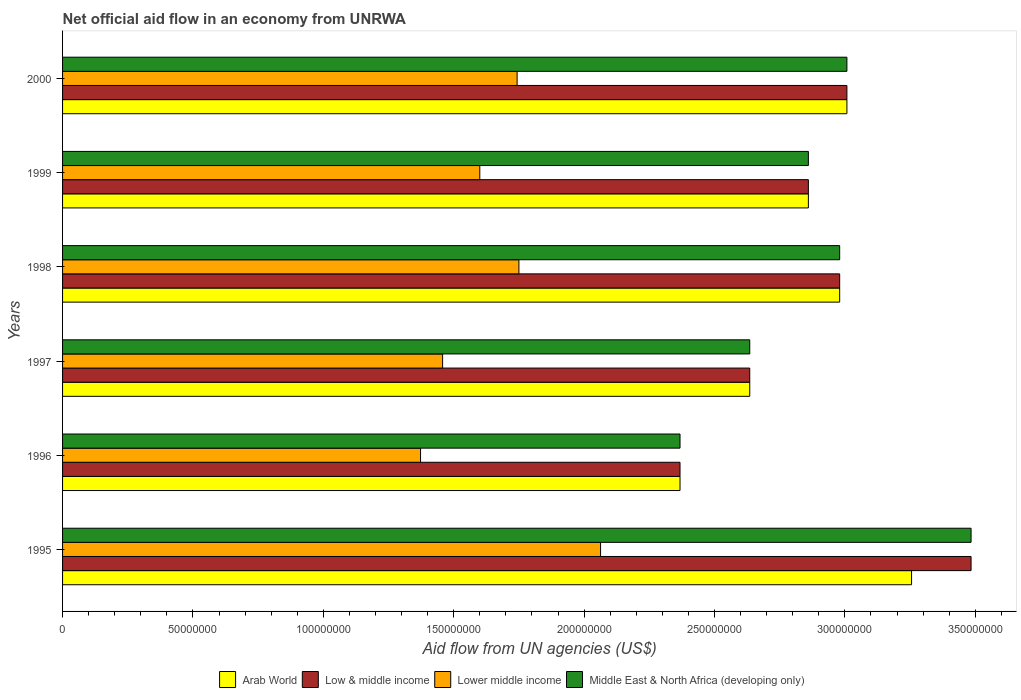How many different coloured bars are there?
Ensure brevity in your answer.  4. How many groups of bars are there?
Your answer should be very brief. 6. Are the number of bars per tick equal to the number of legend labels?
Ensure brevity in your answer.  Yes. How many bars are there on the 5th tick from the top?
Offer a terse response. 4. How many bars are there on the 1st tick from the bottom?
Provide a short and direct response. 4. What is the label of the 5th group of bars from the top?
Keep it short and to the point. 1996. What is the net official aid flow in Lower middle income in 1997?
Keep it short and to the point. 1.46e+08. Across all years, what is the maximum net official aid flow in Middle East & North Africa (developing only)?
Your answer should be very brief. 3.48e+08. Across all years, what is the minimum net official aid flow in Middle East & North Africa (developing only)?
Your answer should be very brief. 2.37e+08. In which year was the net official aid flow in Low & middle income maximum?
Your answer should be compact. 1995. What is the total net official aid flow in Middle East & North Africa (developing only) in the graph?
Offer a terse response. 1.73e+09. What is the difference between the net official aid flow in Middle East & North Africa (developing only) in 1995 and that in 1999?
Keep it short and to the point. 6.24e+07. What is the difference between the net official aid flow in Arab World in 2000 and the net official aid flow in Middle East & North Africa (developing only) in 1999?
Provide a succinct answer. 1.48e+07. What is the average net official aid flow in Lower middle income per year?
Your answer should be compact. 1.66e+08. In the year 1995, what is the difference between the net official aid flow in Middle East & North Africa (developing only) and net official aid flow in Arab World?
Offer a terse response. 2.28e+07. What is the ratio of the net official aid flow in Lower middle income in 1998 to that in 2000?
Your answer should be compact. 1. Is the net official aid flow in Lower middle income in 1997 less than that in 2000?
Provide a succinct answer. Yes. Is the difference between the net official aid flow in Middle East & North Africa (developing only) in 1996 and 1998 greater than the difference between the net official aid flow in Arab World in 1996 and 1998?
Your answer should be very brief. No. What is the difference between the highest and the second highest net official aid flow in Low & middle income?
Keep it short and to the point. 4.76e+07. What is the difference between the highest and the lowest net official aid flow in Low & middle income?
Provide a succinct answer. 1.12e+08. Is the sum of the net official aid flow in Arab World in 1995 and 1999 greater than the maximum net official aid flow in Low & middle income across all years?
Make the answer very short. Yes. Is it the case that in every year, the sum of the net official aid flow in Lower middle income and net official aid flow in Arab World is greater than the sum of net official aid flow in Middle East & North Africa (developing only) and net official aid flow in Low & middle income?
Your response must be concise. No. What does the 1st bar from the top in 1999 represents?
Give a very brief answer. Middle East & North Africa (developing only). What does the 4th bar from the bottom in 1999 represents?
Offer a terse response. Middle East & North Africa (developing only). Is it the case that in every year, the sum of the net official aid flow in Arab World and net official aid flow in Middle East & North Africa (developing only) is greater than the net official aid flow in Low & middle income?
Make the answer very short. Yes. Are all the bars in the graph horizontal?
Provide a succinct answer. Yes. How many years are there in the graph?
Make the answer very short. 6. What is the difference between two consecutive major ticks on the X-axis?
Your answer should be very brief. 5.00e+07. Does the graph contain any zero values?
Ensure brevity in your answer.  No. Does the graph contain grids?
Provide a succinct answer. No. Where does the legend appear in the graph?
Your answer should be very brief. Bottom center. What is the title of the graph?
Keep it short and to the point. Net official aid flow in an economy from UNRWA. What is the label or title of the X-axis?
Provide a short and direct response. Aid flow from UN agencies (US$). What is the label or title of the Y-axis?
Your answer should be compact. Years. What is the Aid flow from UN agencies (US$) in Arab World in 1995?
Provide a succinct answer. 3.26e+08. What is the Aid flow from UN agencies (US$) in Low & middle income in 1995?
Your answer should be very brief. 3.48e+08. What is the Aid flow from UN agencies (US$) in Lower middle income in 1995?
Your answer should be very brief. 2.06e+08. What is the Aid flow from UN agencies (US$) of Middle East & North Africa (developing only) in 1995?
Your response must be concise. 3.48e+08. What is the Aid flow from UN agencies (US$) in Arab World in 1996?
Ensure brevity in your answer.  2.37e+08. What is the Aid flow from UN agencies (US$) of Low & middle income in 1996?
Ensure brevity in your answer.  2.37e+08. What is the Aid flow from UN agencies (US$) in Lower middle income in 1996?
Keep it short and to the point. 1.37e+08. What is the Aid flow from UN agencies (US$) in Middle East & North Africa (developing only) in 1996?
Offer a terse response. 2.37e+08. What is the Aid flow from UN agencies (US$) in Arab World in 1997?
Provide a succinct answer. 2.64e+08. What is the Aid flow from UN agencies (US$) of Low & middle income in 1997?
Your answer should be very brief. 2.64e+08. What is the Aid flow from UN agencies (US$) of Lower middle income in 1997?
Offer a terse response. 1.46e+08. What is the Aid flow from UN agencies (US$) of Middle East & North Africa (developing only) in 1997?
Give a very brief answer. 2.64e+08. What is the Aid flow from UN agencies (US$) in Arab World in 1998?
Your answer should be very brief. 2.98e+08. What is the Aid flow from UN agencies (US$) in Low & middle income in 1998?
Provide a succinct answer. 2.98e+08. What is the Aid flow from UN agencies (US$) of Lower middle income in 1998?
Provide a succinct answer. 1.75e+08. What is the Aid flow from UN agencies (US$) of Middle East & North Africa (developing only) in 1998?
Make the answer very short. 2.98e+08. What is the Aid flow from UN agencies (US$) in Arab World in 1999?
Your answer should be compact. 2.86e+08. What is the Aid flow from UN agencies (US$) of Low & middle income in 1999?
Give a very brief answer. 2.86e+08. What is the Aid flow from UN agencies (US$) of Lower middle income in 1999?
Ensure brevity in your answer.  1.60e+08. What is the Aid flow from UN agencies (US$) of Middle East & North Africa (developing only) in 1999?
Make the answer very short. 2.86e+08. What is the Aid flow from UN agencies (US$) of Arab World in 2000?
Provide a succinct answer. 3.01e+08. What is the Aid flow from UN agencies (US$) of Low & middle income in 2000?
Offer a very short reply. 3.01e+08. What is the Aid flow from UN agencies (US$) in Lower middle income in 2000?
Keep it short and to the point. 1.74e+08. What is the Aid flow from UN agencies (US$) of Middle East & North Africa (developing only) in 2000?
Your answer should be very brief. 3.01e+08. Across all years, what is the maximum Aid flow from UN agencies (US$) of Arab World?
Offer a very short reply. 3.26e+08. Across all years, what is the maximum Aid flow from UN agencies (US$) of Low & middle income?
Keep it short and to the point. 3.48e+08. Across all years, what is the maximum Aid flow from UN agencies (US$) of Lower middle income?
Your answer should be compact. 2.06e+08. Across all years, what is the maximum Aid flow from UN agencies (US$) of Middle East & North Africa (developing only)?
Keep it short and to the point. 3.48e+08. Across all years, what is the minimum Aid flow from UN agencies (US$) of Arab World?
Ensure brevity in your answer.  2.37e+08. Across all years, what is the minimum Aid flow from UN agencies (US$) in Low & middle income?
Provide a succinct answer. 2.37e+08. Across all years, what is the minimum Aid flow from UN agencies (US$) in Lower middle income?
Give a very brief answer. 1.37e+08. Across all years, what is the minimum Aid flow from UN agencies (US$) of Middle East & North Africa (developing only)?
Keep it short and to the point. 2.37e+08. What is the total Aid flow from UN agencies (US$) of Arab World in the graph?
Offer a terse response. 1.71e+09. What is the total Aid flow from UN agencies (US$) in Low & middle income in the graph?
Ensure brevity in your answer.  1.73e+09. What is the total Aid flow from UN agencies (US$) in Lower middle income in the graph?
Offer a very short reply. 9.99e+08. What is the total Aid flow from UN agencies (US$) in Middle East & North Africa (developing only) in the graph?
Ensure brevity in your answer.  1.73e+09. What is the difference between the Aid flow from UN agencies (US$) in Arab World in 1995 and that in 1996?
Give a very brief answer. 8.88e+07. What is the difference between the Aid flow from UN agencies (US$) in Low & middle income in 1995 and that in 1996?
Make the answer very short. 1.12e+08. What is the difference between the Aid flow from UN agencies (US$) of Lower middle income in 1995 and that in 1996?
Your response must be concise. 6.90e+07. What is the difference between the Aid flow from UN agencies (US$) in Middle East & North Africa (developing only) in 1995 and that in 1996?
Ensure brevity in your answer.  1.12e+08. What is the difference between the Aid flow from UN agencies (US$) of Arab World in 1995 and that in 1997?
Make the answer very short. 6.20e+07. What is the difference between the Aid flow from UN agencies (US$) in Low & middle income in 1995 and that in 1997?
Your response must be concise. 8.49e+07. What is the difference between the Aid flow from UN agencies (US$) of Lower middle income in 1995 and that in 1997?
Provide a succinct answer. 6.06e+07. What is the difference between the Aid flow from UN agencies (US$) of Middle East & North Africa (developing only) in 1995 and that in 1997?
Offer a very short reply. 8.49e+07. What is the difference between the Aid flow from UN agencies (US$) of Arab World in 1995 and that in 1998?
Give a very brief answer. 2.76e+07. What is the difference between the Aid flow from UN agencies (US$) in Low & middle income in 1995 and that in 1998?
Your response must be concise. 5.04e+07. What is the difference between the Aid flow from UN agencies (US$) in Lower middle income in 1995 and that in 1998?
Give a very brief answer. 3.13e+07. What is the difference between the Aid flow from UN agencies (US$) in Middle East & North Africa (developing only) in 1995 and that in 1998?
Your answer should be very brief. 5.04e+07. What is the difference between the Aid flow from UN agencies (US$) of Arab World in 1995 and that in 1999?
Your answer should be compact. 3.96e+07. What is the difference between the Aid flow from UN agencies (US$) in Low & middle income in 1995 and that in 1999?
Your answer should be very brief. 6.24e+07. What is the difference between the Aid flow from UN agencies (US$) in Lower middle income in 1995 and that in 1999?
Give a very brief answer. 4.63e+07. What is the difference between the Aid flow from UN agencies (US$) in Middle East & North Africa (developing only) in 1995 and that in 1999?
Provide a short and direct response. 6.24e+07. What is the difference between the Aid flow from UN agencies (US$) in Arab World in 1995 and that in 2000?
Offer a terse response. 2.48e+07. What is the difference between the Aid flow from UN agencies (US$) of Low & middle income in 1995 and that in 2000?
Give a very brief answer. 4.76e+07. What is the difference between the Aid flow from UN agencies (US$) in Lower middle income in 1995 and that in 2000?
Make the answer very short. 3.20e+07. What is the difference between the Aid flow from UN agencies (US$) of Middle East & North Africa (developing only) in 1995 and that in 2000?
Make the answer very short. 4.76e+07. What is the difference between the Aid flow from UN agencies (US$) of Arab World in 1996 and that in 1997?
Make the answer very short. -2.67e+07. What is the difference between the Aid flow from UN agencies (US$) of Low & middle income in 1996 and that in 1997?
Offer a terse response. -2.67e+07. What is the difference between the Aid flow from UN agencies (US$) of Lower middle income in 1996 and that in 1997?
Offer a very short reply. -8.46e+06. What is the difference between the Aid flow from UN agencies (US$) of Middle East & North Africa (developing only) in 1996 and that in 1997?
Provide a short and direct response. -2.67e+07. What is the difference between the Aid flow from UN agencies (US$) of Arab World in 1996 and that in 1998?
Your answer should be compact. -6.12e+07. What is the difference between the Aid flow from UN agencies (US$) in Low & middle income in 1996 and that in 1998?
Your response must be concise. -6.12e+07. What is the difference between the Aid flow from UN agencies (US$) in Lower middle income in 1996 and that in 1998?
Your answer should be compact. -3.77e+07. What is the difference between the Aid flow from UN agencies (US$) in Middle East & North Africa (developing only) in 1996 and that in 1998?
Ensure brevity in your answer.  -6.12e+07. What is the difference between the Aid flow from UN agencies (US$) of Arab World in 1996 and that in 1999?
Make the answer very short. -4.92e+07. What is the difference between the Aid flow from UN agencies (US$) in Low & middle income in 1996 and that in 1999?
Your response must be concise. -4.92e+07. What is the difference between the Aid flow from UN agencies (US$) of Lower middle income in 1996 and that in 1999?
Make the answer very short. -2.27e+07. What is the difference between the Aid flow from UN agencies (US$) in Middle East & North Africa (developing only) in 1996 and that in 1999?
Give a very brief answer. -4.92e+07. What is the difference between the Aid flow from UN agencies (US$) in Arab World in 1996 and that in 2000?
Offer a very short reply. -6.40e+07. What is the difference between the Aid flow from UN agencies (US$) in Low & middle income in 1996 and that in 2000?
Offer a terse response. -6.40e+07. What is the difference between the Aid flow from UN agencies (US$) in Lower middle income in 1996 and that in 2000?
Ensure brevity in your answer.  -3.70e+07. What is the difference between the Aid flow from UN agencies (US$) in Middle East & North Africa (developing only) in 1996 and that in 2000?
Ensure brevity in your answer.  -6.40e+07. What is the difference between the Aid flow from UN agencies (US$) in Arab World in 1997 and that in 1998?
Keep it short and to the point. -3.45e+07. What is the difference between the Aid flow from UN agencies (US$) of Low & middle income in 1997 and that in 1998?
Offer a terse response. -3.45e+07. What is the difference between the Aid flow from UN agencies (US$) in Lower middle income in 1997 and that in 1998?
Give a very brief answer. -2.93e+07. What is the difference between the Aid flow from UN agencies (US$) in Middle East & North Africa (developing only) in 1997 and that in 1998?
Provide a succinct answer. -3.45e+07. What is the difference between the Aid flow from UN agencies (US$) in Arab World in 1997 and that in 1999?
Your response must be concise. -2.25e+07. What is the difference between the Aid flow from UN agencies (US$) in Low & middle income in 1997 and that in 1999?
Give a very brief answer. -2.25e+07. What is the difference between the Aid flow from UN agencies (US$) of Lower middle income in 1997 and that in 1999?
Your answer should be very brief. -1.43e+07. What is the difference between the Aid flow from UN agencies (US$) in Middle East & North Africa (developing only) in 1997 and that in 1999?
Make the answer very short. -2.25e+07. What is the difference between the Aid flow from UN agencies (US$) in Arab World in 1997 and that in 2000?
Make the answer very short. -3.73e+07. What is the difference between the Aid flow from UN agencies (US$) of Low & middle income in 1997 and that in 2000?
Provide a short and direct response. -3.73e+07. What is the difference between the Aid flow from UN agencies (US$) in Lower middle income in 1997 and that in 2000?
Your answer should be very brief. -2.86e+07. What is the difference between the Aid flow from UN agencies (US$) of Middle East & North Africa (developing only) in 1997 and that in 2000?
Make the answer very short. -3.73e+07. What is the difference between the Aid flow from UN agencies (US$) in Low & middle income in 1998 and that in 1999?
Keep it short and to the point. 1.20e+07. What is the difference between the Aid flow from UN agencies (US$) of Lower middle income in 1998 and that in 1999?
Make the answer very short. 1.50e+07. What is the difference between the Aid flow from UN agencies (US$) of Arab World in 1998 and that in 2000?
Your answer should be very brief. -2.78e+06. What is the difference between the Aid flow from UN agencies (US$) in Low & middle income in 1998 and that in 2000?
Your answer should be compact. -2.78e+06. What is the difference between the Aid flow from UN agencies (US$) of Lower middle income in 1998 and that in 2000?
Offer a very short reply. 6.90e+05. What is the difference between the Aid flow from UN agencies (US$) in Middle East & North Africa (developing only) in 1998 and that in 2000?
Your answer should be very brief. -2.78e+06. What is the difference between the Aid flow from UN agencies (US$) of Arab World in 1999 and that in 2000?
Make the answer very short. -1.48e+07. What is the difference between the Aid flow from UN agencies (US$) of Low & middle income in 1999 and that in 2000?
Provide a short and direct response. -1.48e+07. What is the difference between the Aid flow from UN agencies (US$) in Lower middle income in 1999 and that in 2000?
Keep it short and to the point. -1.43e+07. What is the difference between the Aid flow from UN agencies (US$) in Middle East & North Africa (developing only) in 1999 and that in 2000?
Offer a very short reply. -1.48e+07. What is the difference between the Aid flow from UN agencies (US$) in Arab World in 1995 and the Aid flow from UN agencies (US$) in Low & middle income in 1996?
Keep it short and to the point. 8.88e+07. What is the difference between the Aid flow from UN agencies (US$) in Arab World in 1995 and the Aid flow from UN agencies (US$) in Lower middle income in 1996?
Your answer should be very brief. 1.88e+08. What is the difference between the Aid flow from UN agencies (US$) in Arab World in 1995 and the Aid flow from UN agencies (US$) in Middle East & North Africa (developing only) in 1996?
Provide a succinct answer. 8.88e+07. What is the difference between the Aid flow from UN agencies (US$) in Low & middle income in 1995 and the Aid flow from UN agencies (US$) in Lower middle income in 1996?
Your answer should be very brief. 2.11e+08. What is the difference between the Aid flow from UN agencies (US$) in Low & middle income in 1995 and the Aid flow from UN agencies (US$) in Middle East & North Africa (developing only) in 1996?
Ensure brevity in your answer.  1.12e+08. What is the difference between the Aid flow from UN agencies (US$) in Lower middle income in 1995 and the Aid flow from UN agencies (US$) in Middle East & North Africa (developing only) in 1996?
Make the answer very short. -3.05e+07. What is the difference between the Aid flow from UN agencies (US$) in Arab World in 1995 and the Aid flow from UN agencies (US$) in Low & middle income in 1997?
Provide a short and direct response. 6.20e+07. What is the difference between the Aid flow from UN agencies (US$) in Arab World in 1995 and the Aid flow from UN agencies (US$) in Lower middle income in 1997?
Your response must be concise. 1.80e+08. What is the difference between the Aid flow from UN agencies (US$) of Arab World in 1995 and the Aid flow from UN agencies (US$) of Middle East & North Africa (developing only) in 1997?
Your answer should be compact. 6.20e+07. What is the difference between the Aid flow from UN agencies (US$) of Low & middle income in 1995 and the Aid flow from UN agencies (US$) of Lower middle income in 1997?
Offer a very short reply. 2.03e+08. What is the difference between the Aid flow from UN agencies (US$) in Low & middle income in 1995 and the Aid flow from UN agencies (US$) in Middle East & North Africa (developing only) in 1997?
Offer a terse response. 8.49e+07. What is the difference between the Aid flow from UN agencies (US$) of Lower middle income in 1995 and the Aid flow from UN agencies (US$) of Middle East & North Africa (developing only) in 1997?
Give a very brief answer. -5.72e+07. What is the difference between the Aid flow from UN agencies (US$) of Arab World in 1995 and the Aid flow from UN agencies (US$) of Low & middle income in 1998?
Make the answer very short. 2.76e+07. What is the difference between the Aid flow from UN agencies (US$) in Arab World in 1995 and the Aid flow from UN agencies (US$) in Lower middle income in 1998?
Your response must be concise. 1.51e+08. What is the difference between the Aid flow from UN agencies (US$) of Arab World in 1995 and the Aid flow from UN agencies (US$) of Middle East & North Africa (developing only) in 1998?
Your response must be concise. 2.76e+07. What is the difference between the Aid flow from UN agencies (US$) in Low & middle income in 1995 and the Aid flow from UN agencies (US$) in Lower middle income in 1998?
Give a very brief answer. 1.73e+08. What is the difference between the Aid flow from UN agencies (US$) of Low & middle income in 1995 and the Aid flow from UN agencies (US$) of Middle East & North Africa (developing only) in 1998?
Make the answer very short. 5.04e+07. What is the difference between the Aid flow from UN agencies (US$) in Lower middle income in 1995 and the Aid flow from UN agencies (US$) in Middle East & North Africa (developing only) in 1998?
Your answer should be compact. -9.17e+07. What is the difference between the Aid flow from UN agencies (US$) of Arab World in 1995 and the Aid flow from UN agencies (US$) of Low & middle income in 1999?
Keep it short and to the point. 3.96e+07. What is the difference between the Aid flow from UN agencies (US$) of Arab World in 1995 and the Aid flow from UN agencies (US$) of Lower middle income in 1999?
Your response must be concise. 1.66e+08. What is the difference between the Aid flow from UN agencies (US$) in Arab World in 1995 and the Aid flow from UN agencies (US$) in Middle East & North Africa (developing only) in 1999?
Your response must be concise. 3.96e+07. What is the difference between the Aid flow from UN agencies (US$) of Low & middle income in 1995 and the Aid flow from UN agencies (US$) of Lower middle income in 1999?
Provide a short and direct response. 1.88e+08. What is the difference between the Aid flow from UN agencies (US$) of Low & middle income in 1995 and the Aid flow from UN agencies (US$) of Middle East & North Africa (developing only) in 1999?
Offer a very short reply. 6.24e+07. What is the difference between the Aid flow from UN agencies (US$) in Lower middle income in 1995 and the Aid flow from UN agencies (US$) in Middle East & North Africa (developing only) in 1999?
Offer a very short reply. -7.97e+07. What is the difference between the Aid flow from UN agencies (US$) of Arab World in 1995 and the Aid flow from UN agencies (US$) of Low & middle income in 2000?
Your response must be concise. 2.48e+07. What is the difference between the Aid flow from UN agencies (US$) in Arab World in 1995 and the Aid flow from UN agencies (US$) in Lower middle income in 2000?
Keep it short and to the point. 1.51e+08. What is the difference between the Aid flow from UN agencies (US$) of Arab World in 1995 and the Aid flow from UN agencies (US$) of Middle East & North Africa (developing only) in 2000?
Make the answer very short. 2.48e+07. What is the difference between the Aid flow from UN agencies (US$) of Low & middle income in 1995 and the Aid flow from UN agencies (US$) of Lower middle income in 2000?
Provide a short and direct response. 1.74e+08. What is the difference between the Aid flow from UN agencies (US$) of Low & middle income in 1995 and the Aid flow from UN agencies (US$) of Middle East & North Africa (developing only) in 2000?
Give a very brief answer. 4.76e+07. What is the difference between the Aid flow from UN agencies (US$) in Lower middle income in 1995 and the Aid flow from UN agencies (US$) in Middle East & North Africa (developing only) in 2000?
Your answer should be very brief. -9.45e+07. What is the difference between the Aid flow from UN agencies (US$) of Arab World in 1996 and the Aid flow from UN agencies (US$) of Low & middle income in 1997?
Give a very brief answer. -2.67e+07. What is the difference between the Aid flow from UN agencies (US$) in Arab World in 1996 and the Aid flow from UN agencies (US$) in Lower middle income in 1997?
Your answer should be compact. 9.10e+07. What is the difference between the Aid flow from UN agencies (US$) of Arab World in 1996 and the Aid flow from UN agencies (US$) of Middle East & North Africa (developing only) in 1997?
Offer a very short reply. -2.67e+07. What is the difference between the Aid flow from UN agencies (US$) in Low & middle income in 1996 and the Aid flow from UN agencies (US$) in Lower middle income in 1997?
Offer a very short reply. 9.10e+07. What is the difference between the Aid flow from UN agencies (US$) of Low & middle income in 1996 and the Aid flow from UN agencies (US$) of Middle East & North Africa (developing only) in 1997?
Keep it short and to the point. -2.67e+07. What is the difference between the Aid flow from UN agencies (US$) of Lower middle income in 1996 and the Aid flow from UN agencies (US$) of Middle East & North Africa (developing only) in 1997?
Make the answer very short. -1.26e+08. What is the difference between the Aid flow from UN agencies (US$) of Arab World in 1996 and the Aid flow from UN agencies (US$) of Low & middle income in 1998?
Your response must be concise. -6.12e+07. What is the difference between the Aid flow from UN agencies (US$) in Arab World in 1996 and the Aid flow from UN agencies (US$) in Lower middle income in 1998?
Give a very brief answer. 6.18e+07. What is the difference between the Aid flow from UN agencies (US$) in Arab World in 1996 and the Aid flow from UN agencies (US$) in Middle East & North Africa (developing only) in 1998?
Offer a terse response. -6.12e+07. What is the difference between the Aid flow from UN agencies (US$) of Low & middle income in 1996 and the Aid flow from UN agencies (US$) of Lower middle income in 1998?
Ensure brevity in your answer.  6.18e+07. What is the difference between the Aid flow from UN agencies (US$) of Low & middle income in 1996 and the Aid flow from UN agencies (US$) of Middle East & North Africa (developing only) in 1998?
Your response must be concise. -6.12e+07. What is the difference between the Aid flow from UN agencies (US$) in Lower middle income in 1996 and the Aid flow from UN agencies (US$) in Middle East & North Africa (developing only) in 1998?
Offer a very short reply. -1.61e+08. What is the difference between the Aid flow from UN agencies (US$) in Arab World in 1996 and the Aid flow from UN agencies (US$) in Low & middle income in 1999?
Offer a very short reply. -4.92e+07. What is the difference between the Aid flow from UN agencies (US$) of Arab World in 1996 and the Aid flow from UN agencies (US$) of Lower middle income in 1999?
Give a very brief answer. 7.68e+07. What is the difference between the Aid flow from UN agencies (US$) of Arab World in 1996 and the Aid flow from UN agencies (US$) of Middle East & North Africa (developing only) in 1999?
Keep it short and to the point. -4.92e+07. What is the difference between the Aid flow from UN agencies (US$) in Low & middle income in 1996 and the Aid flow from UN agencies (US$) in Lower middle income in 1999?
Offer a terse response. 7.68e+07. What is the difference between the Aid flow from UN agencies (US$) in Low & middle income in 1996 and the Aid flow from UN agencies (US$) in Middle East & North Africa (developing only) in 1999?
Offer a very short reply. -4.92e+07. What is the difference between the Aid flow from UN agencies (US$) in Lower middle income in 1996 and the Aid flow from UN agencies (US$) in Middle East & North Africa (developing only) in 1999?
Make the answer very short. -1.49e+08. What is the difference between the Aid flow from UN agencies (US$) of Arab World in 1996 and the Aid flow from UN agencies (US$) of Low & middle income in 2000?
Provide a short and direct response. -6.40e+07. What is the difference between the Aid flow from UN agencies (US$) in Arab World in 1996 and the Aid flow from UN agencies (US$) in Lower middle income in 2000?
Give a very brief answer. 6.25e+07. What is the difference between the Aid flow from UN agencies (US$) of Arab World in 1996 and the Aid flow from UN agencies (US$) of Middle East & North Africa (developing only) in 2000?
Offer a very short reply. -6.40e+07. What is the difference between the Aid flow from UN agencies (US$) of Low & middle income in 1996 and the Aid flow from UN agencies (US$) of Lower middle income in 2000?
Offer a very short reply. 6.25e+07. What is the difference between the Aid flow from UN agencies (US$) of Low & middle income in 1996 and the Aid flow from UN agencies (US$) of Middle East & North Africa (developing only) in 2000?
Your answer should be compact. -6.40e+07. What is the difference between the Aid flow from UN agencies (US$) of Lower middle income in 1996 and the Aid flow from UN agencies (US$) of Middle East & North Africa (developing only) in 2000?
Provide a short and direct response. -1.64e+08. What is the difference between the Aid flow from UN agencies (US$) of Arab World in 1997 and the Aid flow from UN agencies (US$) of Low & middle income in 1998?
Your answer should be compact. -3.45e+07. What is the difference between the Aid flow from UN agencies (US$) in Arab World in 1997 and the Aid flow from UN agencies (US$) in Lower middle income in 1998?
Ensure brevity in your answer.  8.85e+07. What is the difference between the Aid flow from UN agencies (US$) in Arab World in 1997 and the Aid flow from UN agencies (US$) in Middle East & North Africa (developing only) in 1998?
Your response must be concise. -3.45e+07. What is the difference between the Aid flow from UN agencies (US$) in Low & middle income in 1997 and the Aid flow from UN agencies (US$) in Lower middle income in 1998?
Provide a succinct answer. 8.85e+07. What is the difference between the Aid flow from UN agencies (US$) in Low & middle income in 1997 and the Aid flow from UN agencies (US$) in Middle East & North Africa (developing only) in 1998?
Offer a terse response. -3.45e+07. What is the difference between the Aid flow from UN agencies (US$) of Lower middle income in 1997 and the Aid flow from UN agencies (US$) of Middle East & North Africa (developing only) in 1998?
Make the answer very short. -1.52e+08. What is the difference between the Aid flow from UN agencies (US$) in Arab World in 1997 and the Aid flow from UN agencies (US$) in Low & middle income in 1999?
Your answer should be very brief. -2.25e+07. What is the difference between the Aid flow from UN agencies (US$) of Arab World in 1997 and the Aid flow from UN agencies (US$) of Lower middle income in 1999?
Give a very brief answer. 1.04e+08. What is the difference between the Aid flow from UN agencies (US$) in Arab World in 1997 and the Aid flow from UN agencies (US$) in Middle East & North Africa (developing only) in 1999?
Keep it short and to the point. -2.25e+07. What is the difference between the Aid flow from UN agencies (US$) of Low & middle income in 1997 and the Aid flow from UN agencies (US$) of Lower middle income in 1999?
Make the answer very short. 1.04e+08. What is the difference between the Aid flow from UN agencies (US$) in Low & middle income in 1997 and the Aid flow from UN agencies (US$) in Middle East & North Africa (developing only) in 1999?
Offer a very short reply. -2.25e+07. What is the difference between the Aid flow from UN agencies (US$) of Lower middle income in 1997 and the Aid flow from UN agencies (US$) of Middle East & North Africa (developing only) in 1999?
Provide a succinct answer. -1.40e+08. What is the difference between the Aid flow from UN agencies (US$) in Arab World in 1997 and the Aid flow from UN agencies (US$) in Low & middle income in 2000?
Provide a short and direct response. -3.73e+07. What is the difference between the Aid flow from UN agencies (US$) in Arab World in 1997 and the Aid flow from UN agencies (US$) in Lower middle income in 2000?
Your answer should be very brief. 8.92e+07. What is the difference between the Aid flow from UN agencies (US$) in Arab World in 1997 and the Aid flow from UN agencies (US$) in Middle East & North Africa (developing only) in 2000?
Your answer should be compact. -3.73e+07. What is the difference between the Aid flow from UN agencies (US$) of Low & middle income in 1997 and the Aid flow from UN agencies (US$) of Lower middle income in 2000?
Make the answer very short. 8.92e+07. What is the difference between the Aid flow from UN agencies (US$) of Low & middle income in 1997 and the Aid flow from UN agencies (US$) of Middle East & North Africa (developing only) in 2000?
Your response must be concise. -3.73e+07. What is the difference between the Aid flow from UN agencies (US$) of Lower middle income in 1997 and the Aid flow from UN agencies (US$) of Middle East & North Africa (developing only) in 2000?
Your answer should be very brief. -1.55e+08. What is the difference between the Aid flow from UN agencies (US$) of Arab World in 1998 and the Aid flow from UN agencies (US$) of Lower middle income in 1999?
Your answer should be very brief. 1.38e+08. What is the difference between the Aid flow from UN agencies (US$) of Arab World in 1998 and the Aid flow from UN agencies (US$) of Middle East & North Africa (developing only) in 1999?
Provide a succinct answer. 1.20e+07. What is the difference between the Aid flow from UN agencies (US$) of Low & middle income in 1998 and the Aid flow from UN agencies (US$) of Lower middle income in 1999?
Provide a succinct answer. 1.38e+08. What is the difference between the Aid flow from UN agencies (US$) of Low & middle income in 1998 and the Aid flow from UN agencies (US$) of Middle East & North Africa (developing only) in 1999?
Provide a short and direct response. 1.20e+07. What is the difference between the Aid flow from UN agencies (US$) of Lower middle income in 1998 and the Aid flow from UN agencies (US$) of Middle East & North Africa (developing only) in 1999?
Your response must be concise. -1.11e+08. What is the difference between the Aid flow from UN agencies (US$) of Arab World in 1998 and the Aid flow from UN agencies (US$) of Low & middle income in 2000?
Offer a terse response. -2.78e+06. What is the difference between the Aid flow from UN agencies (US$) of Arab World in 1998 and the Aid flow from UN agencies (US$) of Lower middle income in 2000?
Provide a succinct answer. 1.24e+08. What is the difference between the Aid flow from UN agencies (US$) of Arab World in 1998 and the Aid flow from UN agencies (US$) of Middle East & North Africa (developing only) in 2000?
Ensure brevity in your answer.  -2.78e+06. What is the difference between the Aid flow from UN agencies (US$) in Low & middle income in 1998 and the Aid flow from UN agencies (US$) in Lower middle income in 2000?
Provide a succinct answer. 1.24e+08. What is the difference between the Aid flow from UN agencies (US$) in Low & middle income in 1998 and the Aid flow from UN agencies (US$) in Middle East & North Africa (developing only) in 2000?
Provide a short and direct response. -2.78e+06. What is the difference between the Aid flow from UN agencies (US$) in Lower middle income in 1998 and the Aid flow from UN agencies (US$) in Middle East & North Africa (developing only) in 2000?
Your answer should be compact. -1.26e+08. What is the difference between the Aid flow from UN agencies (US$) of Arab World in 1999 and the Aid flow from UN agencies (US$) of Low & middle income in 2000?
Your answer should be very brief. -1.48e+07. What is the difference between the Aid flow from UN agencies (US$) of Arab World in 1999 and the Aid flow from UN agencies (US$) of Lower middle income in 2000?
Offer a terse response. 1.12e+08. What is the difference between the Aid flow from UN agencies (US$) of Arab World in 1999 and the Aid flow from UN agencies (US$) of Middle East & North Africa (developing only) in 2000?
Give a very brief answer. -1.48e+07. What is the difference between the Aid flow from UN agencies (US$) of Low & middle income in 1999 and the Aid flow from UN agencies (US$) of Lower middle income in 2000?
Offer a terse response. 1.12e+08. What is the difference between the Aid flow from UN agencies (US$) in Low & middle income in 1999 and the Aid flow from UN agencies (US$) in Middle East & North Africa (developing only) in 2000?
Ensure brevity in your answer.  -1.48e+07. What is the difference between the Aid flow from UN agencies (US$) of Lower middle income in 1999 and the Aid flow from UN agencies (US$) of Middle East & North Africa (developing only) in 2000?
Offer a terse response. -1.41e+08. What is the average Aid flow from UN agencies (US$) of Arab World per year?
Your answer should be very brief. 2.85e+08. What is the average Aid flow from UN agencies (US$) of Low & middle income per year?
Your answer should be compact. 2.89e+08. What is the average Aid flow from UN agencies (US$) of Lower middle income per year?
Keep it short and to the point. 1.66e+08. What is the average Aid flow from UN agencies (US$) of Middle East & North Africa (developing only) per year?
Your response must be concise. 2.89e+08. In the year 1995, what is the difference between the Aid flow from UN agencies (US$) in Arab World and Aid flow from UN agencies (US$) in Low & middle income?
Provide a short and direct response. -2.28e+07. In the year 1995, what is the difference between the Aid flow from UN agencies (US$) of Arab World and Aid flow from UN agencies (US$) of Lower middle income?
Ensure brevity in your answer.  1.19e+08. In the year 1995, what is the difference between the Aid flow from UN agencies (US$) in Arab World and Aid flow from UN agencies (US$) in Middle East & North Africa (developing only)?
Keep it short and to the point. -2.28e+07. In the year 1995, what is the difference between the Aid flow from UN agencies (US$) in Low & middle income and Aid flow from UN agencies (US$) in Lower middle income?
Provide a short and direct response. 1.42e+08. In the year 1995, what is the difference between the Aid flow from UN agencies (US$) of Low & middle income and Aid flow from UN agencies (US$) of Middle East & North Africa (developing only)?
Make the answer very short. 0. In the year 1995, what is the difference between the Aid flow from UN agencies (US$) in Lower middle income and Aid flow from UN agencies (US$) in Middle East & North Africa (developing only)?
Your response must be concise. -1.42e+08. In the year 1996, what is the difference between the Aid flow from UN agencies (US$) in Arab World and Aid flow from UN agencies (US$) in Lower middle income?
Your response must be concise. 9.95e+07. In the year 1996, what is the difference between the Aid flow from UN agencies (US$) in Arab World and Aid flow from UN agencies (US$) in Middle East & North Africa (developing only)?
Your answer should be very brief. 0. In the year 1996, what is the difference between the Aid flow from UN agencies (US$) in Low & middle income and Aid flow from UN agencies (US$) in Lower middle income?
Your response must be concise. 9.95e+07. In the year 1996, what is the difference between the Aid flow from UN agencies (US$) in Lower middle income and Aid flow from UN agencies (US$) in Middle East & North Africa (developing only)?
Keep it short and to the point. -9.95e+07. In the year 1997, what is the difference between the Aid flow from UN agencies (US$) in Arab World and Aid flow from UN agencies (US$) in Low & middle income?
Your response must be concise. 0. In the year 1997, what is the difference between the Aid flow from UN agencies (US$) of Arab World and Aid flow from UN agencies (US$) of Lower middle income?
Make the answer very short. 1.18e+08. In the year 1997, what is the difference between the Aid flow from UN agencies (US$) of Arab World and Aid flow from UN agencies (US$) of Middle East & North Africa (developing only)?
Your answer should be very brief. 0. In the year 1997, what is the difference between the Aid flow from UN agencies (US$) of Low & middle income and Aid flow from UN agencies (US$) of Lower middle income?
Offer a very short reply. 1.18e+08. In the year 1997, what is the difference between the Aid flow from UN agencies (US$) of Lower middle income and Aid flow from UN agencies (US$) of Middle East & North Africa (developing only)?
Keep it short and to the point. -1.18e+08. In the year 1998, what is the difference between the Aid flow from UN agencies (US$) of Arab World and Aid flow from UN agencies (US$) of Low & middle income?
Your answer should be very brief. 0. In the year 1998, what is the difference between the Aid flow from UN agencies (US$) of Arab World and Aid flow from UN agencies (US$) of Lower middle income?
Ensure brevity in your answer.  1.23e+08. In the year 1998, what is the difference between the Aid flow from UN agencies (US$) in Arab World and Aid flow from UN agencies (US$) in Middle East & North Africa (developing only)?
Give a very brief answer. 0. In the year 1998, what is the difference between the Aid flow from UN agencies (US$) of Low & middle income and Aid flow from UN agencies (US$) of Lower middle income?
Your response must be concise. 1.23e+08. In the year 1998, what is the difference between the Aid flow from UN agencies (US$) in Low & middle income and Aid flow from UN agencies (US$) in Middle East & North Africa (developing only)?
Give a very brief answer. 0. In the year 1998, what is the difference between the Aid flow from UN agencies (US$) in Lower middle income and Aid flow from UN agencies (US$) in Middle East & North Africa (developing only)?
Provide a short and direct response. -1.23e+08. In the year 1999, what is the difference between the Aid flow from UN agencies (US$) in Arab World and Aid flow from UN agencies (US$) in Lower middle income?
Your answer should be very brief. 1.26e+08. In the year 1999, what is the difference between the Aid flow from UN agencies (US$) in Low & middle income and Aid flow from UN agencies (US$) in Lower middle income?
Provide a succinct answer. 1.26e+08. In the year 1999, what is the difference between the Aid flow from UN agencies (US$) of Low & middle income and Aid flow from UN agencies (US$) of Middle East & North Africa (developing only)?
Your response must be concise. 0. In the year 1999, what is the difference between the Aid flow from UN agencies (US$) of Lower middle income and Aid flow from UN agencies (US$) of Middle East & North Africa (developing only)?
Keep it short and to the point. -1.26e+08. In the year 2000, what is the difference between the Aid flow from UN agencies (US$) of Arab World and Aid flow from UN agencies (US$) of Low & middle income?
Provide a succinct answer. 0. In the year 2000, what is the difference between the Aid flow from UN agencies (US$) in Arab World and Aid flow from UN agencies (US$) in Lower middle income?
Provide a succinct answer. 1.26e+08. In the year 2000, what is the difference between the Aid flow from UN agencies (US$) in Low & middle income and Aid flow from UN agencies (US$) in Lower middle income?
Offer a very short reply. 1.26e+08. In the year 2000, what is the difference between the Aid flow from UN agencies (US$) of Low & middle income and Aid flow from UN agencies (US$) of Middle East & North Africa (developing only)?
Provide a short and direct response. 0. In the year 2000, what is the difference between the Aid flow from UN agencies (US$) of Lower middle income and Aid flow from UN agencies (US$) of Middle East & North Africa (developing only)?
Give a very brief answer. -1.26e+08. What is the ratio of the Aid flow from UN agencies (US$) of Arab World in 1995 to that in 1996?
Your answer should be very brief. 1.38. What is the ratio of the Aid flow from UN agencies (US$) in Low & middle income in 1995 to that in 1996?
Provide a succinct answer. 1.47. What is the ratio of the Aid flow from UN agencies (US$) in Lower middle income in 1995 to that in 1996?
Your answer should be compact. 1.5. What is the ratio of the Aid flow from UN agencies (US$) in Middle East & North Africa (developing only) in 1995 to that in 1996?
Provide a succinct answer. 1.47. What is the ratio of the Aid flow from UN agencies (US$) in Arab World in 1995 to that in 1997?
Your answer should be compact. 1.24. What is the ratio of the Aid flow from UN agencies (US$) in Low & middle income in 1995 to that in 1997?
Keep it short and to the point. 1.32. What is the ratio of the Aid flow from UN agencies (US$) in Lower middle income in 1995 to that in 1997?
Make the answer very short. 1.42. What is the ratio of the Aid flow from UN agencies (US$) of Middle East & North Africa (developing only) in 1995 to that in 1997?
Offer a terse response. 1.32. What is the ratio of the Aid flow from UN agencies (US$) in Arab World in 1995 to that in 1998?
Provide a succinct answer. 1.09. What is the ratio of the Aid flow from UN agencies (US$) of Low & middle income in 1995 to that in 1998?
Make the answer very short. 1.17. What is the ratio of the Aid flow from UN agencies (US$) in Lower middle income in 1995 to that in 1998?
Give a very brief answer. 1.18. What is the ratio of the Aid flow from UN agencies (US$) in Middle East & North Africa (developing only) in 1995 to that in 1998?
Your response must be concise. 1.17. What is the ratio of the Aid flow from UN agencies (US$) in Arab World in 1995 to that in 1999?
Your answer should be compact. 1.14. What is the ratio of the Aid flow from UN agencies (US$) of Low & middle income in 1995 to that in 1999?
Make the answer very short. 1.22. What is the ratio of the Aid flow from UN agencies (US$) of Lower middle income in 1995 to that in 1999?
Provide a succinct answer. 1.29. What is the ratio of the Aid flow from UN agencies (US$) of Middle East & North Africa (developing only) in 1995 to that in 1999?
Your response must be concise. 1.22. What is the ratio of the Aid flow from UN agencies (US$) in Arab World in 1995 to that in 2000?
Provide a succinct answer. 1.08. What is the ratio of the Aid flow from UN agencies (US$) in Low & middle income in 1995 to that in 2000?
Keep it short and to the point. 1.16. What is the ratio of the Aid flow from UN agencies (US$) of Lower middle income in 1995 to that in 2000?
Make the answer very short. 1.18. What is the ratio of the Aid flow from UN agencies (US$) of Middle East & North Africa (developing only) in 1995 to that in 2000?
Make the answer very short. 1.16. What is the ratio of the Aid flow from UN agencies (US$) in Arab World in 1996 to that in 1997?
Your answer should be very brief. 0.9. What is the ratio of the Aid flow from UN agencies (US$) of Low & middle income in 1996 to that in 1997?
Provide a short and direct response. 0.9. What is the ratio of the Aid flow from UN agencies (US$) of Lower middle income in 1996 to that in 1997?
Give a very brief answer. 0.94. What is the ratio of the Aid flow from UN agencies (US$) in Middle East & North Africa (developing only) in 1996 to that in 1997?
Your response must be concise. 0.9. What is the ratio of the Aid flow from UN agencies (US$) of Arab World in 1996 to that in 1998?
Offer a very short reply. 0.79. What is the ratio of the Aid flow from UN agencies (US$) of Low & middle income in 1996 to that in 1998?
Give a very brief answer. 0.79. What is the ratio of the Aid flow from UN agencies (US$) of Lower middle income in 1996 to that in 1998?
Offer a terse response. 0.78. What is the ratio of the Aid flow from UN agencies (US$) of Middle East & North Africa (developing only) in 1996 to that in 1998?
Your answer should be compact. 0.79. What is the ratio of the Aid flow from UN agencies (US$) of Arab World in 1996 to that in 1999?
Offer a terse response. 0.83. What is the ratio of the Aid flow from UN agencies (US$) in Low & middle income in 1996 to that in 1999?
Keep it short and to the point. 0.83. What is the ratio of the Aid flow from UN agencies (US$) of Lower middle income in 1996 to that in 1999?
Keep it short and to the point. 0.86. What is the ratio of the Aid flow from UN agencies (US$) of Middle East & North Africa (developing only) in 1996 to that in 1999?
Ensure brevity in your answer.  0.83. What is the ratio of the Aid flow from UN agencies (US$) of Arab World in 1996 to that in 2000?
Offer a terse response. 0.79. What is the ratio of the Aid flow from UN agencies (US$) in Low & middle income in 1996 to that in 2000?
Your response must be concise. 0.79. What is the ratio of the Aid flow from UN agencies (US$) of Lower middle income in 1996 to that in 2000?
Give a very brief answer. 0.79. What is the ratio of the Aid flow from UN agencies (US$) in Middle East & North Africa (developing only) in 1996 to that in 2000?
Your answer should be very brief. 0.79. What is the ratio of the Aid flow from UN agencies (US$) of Arab World in 1997 to that in 1998?
Your answer should be very brief. 0.88. What is the ratio of the Aid flow from UN agencies (US$) of Low & middle income in 1997 to that in 1998?
Provide a short and direct response. 0.88. What is the ratio of the Aid flow from UN agencies (US$) of Lower middle income in 1997 to that in 1998?
Ensure brevity in your answer.  0.83. What is the ratio of the Aid flow from UN agencies (US$) of Middle East & North Africa (developing only) in 1997 to that in 1998?
Offer a very short reply. 0.88. What is the ratio of the Aid flow from UN agencies (US$) in Arab World in 1997 to that in 1999?
Ensure brevity in your answer.  0.92. What is the ratio of the Aid flow from UN agencies (US$) of Low & middle income in 1997 to that in 1999?
Provide a short and direct response. 0.92. What is the ratio of the Aid flow from UN agencies (US$) in Lower middle income in 1997 to that in 1999?
Provide a short and direct response. 0.91. What is the ratio of the Aid flow from UN agencies (US$) in Middle East & North Africa (developing only) in 1997 to that in 1999?
Offer a terse response. 0.92. What is the ratio of the Aid flow from UN agencies (US$) in Arab World in 1997 to that in 2000?
Ensure brevity in your answer.  0.88. What is the ratio of the Aid flow from UN agencies (US$) of Low & middle income in 1997 to that in 2000?
Provide a succinct answer. 0.88. What is the ratio of the Aid flow from UN agencies (US$) in Lower middle income in 1997 to that in 2000?
Ensure brevity in your answer.  0.84. What is the ratio of the Aid flow from UN agencies (US$) in Middle East & North Africa (developing only) in 1997 to that in 2000?
Give a very brief answer. 0.88. What is the ratio of the Aid flow from UN agencies (US$) in Arab World in 1998 to that in 1999?
Your answer should be very brief. 1.04. What is the ratio of the Aid flow from UN agencies (US$) in Low & middle income in 1998 to that in 1999?
Provide a short and direct response. 1.04. What is the ratio of the Aid flow from UN agencies (US$) of Lower middle income in 1998 to that in 1999?
Make the answer very short. 1.09. What is the ratio of the Aid flow from UN agencies (US$) in Middle East & North Africa (developing only) in 1998 to that in 1999?
Give a very brief answer. 1.04. What is the ratio of the Aid flow from UN agencies (US$) in Arab World in 1998 to that in 2000?
Ensure brevity in your answer.  0.99. What is the ratio of the Aid flow from UN agencies (US$) in Low & middle income in 1998 to that in 2000?
Offer a terse response. 0.99. What is the ratio of the Aid flow from UN agencies (US$) in Arab World in 1999 to that in 2000?
Ensure brevity in your answer.  0.95. What is the ratio of the Aid flow from UN agencies (US$) in Low & middle income in 1999 to that in 2000?
Keep it short and to the point. 0.95. What is the ratio of the Aid flow from UN agencies (US$) in Lower middle income in 1999 to that in 2000?
Offer a very short reply. 0.92. What is the ratio of the Aid flow from UN agencies (US$) in Middle East & North Africa (developing only) in 1999 to that in 2000?
Your response must be concise. 0.95. What is the difference between the highest and the second highest Aid flow from UN agencies (US$) in Arab World?
Keep it short and to the point. 2.48e+07. What is the difference between the highest and the second highest Aid flow from UN agencies (US$) of Low & middle income?
Provide a short and direct response. 4.76e+07. What is the difference between the highest and the second highest Aid flow from UN agencies (US$) of Lower middle income?
Your answer should be compact. 3.13e+07. What is the difference between the highest and the second highest Aid flow from UN agencies (US$) in Middle East & North Africa (developing only)?
Give a very brief answer. 4.76e+07. What is the difference between the highest and the lowest Aid flow from UN agencies (US$) in Arab World?
Your answer should be compact. 8.88e+07. What is the difference between the highest and the lowest Aid flow from UN agencies (US$) in Low & middle income?
Give a very brief answer. 1.12e+08. What is the difference between the highest and the lowest Aid flow from UN agencies (US$) of Lower middle income?
Offer a very short reply. 6.90e+07. What is the difference between the highest and the lowest Aid flow from UN agencies (US$) in Middle East & North Africa (developing only)?
Ensure brevity in your answer.  1.12e+08. 